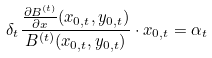Convert formula to latex. <formula><loc_0><loc_0><loc_500><loc_500>\delta _ { t } \frac { \frac { \partial B ^ { ( t ) } } { \partial x } ( x _ { 0 , t } , y _ { 0 , t } ) } { B ^ { ( t ) } ( x _ { 0 , t } , y _ { 0 , t } ) } \cdot x _ { 0 , t } = \alpha _ { t }</formula> 